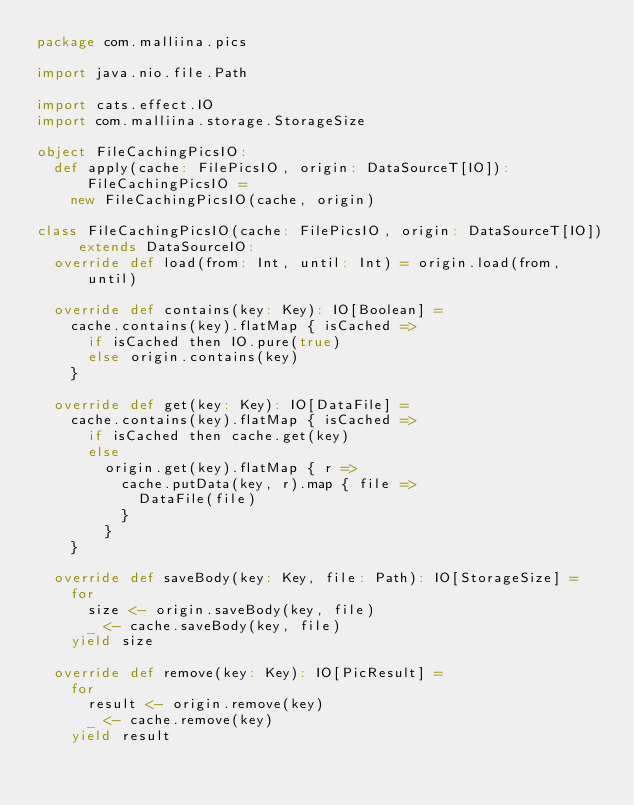Convert code to text. <code><loc_0><loc_0><loc_500><loc_500><_Scala_>package com.malliina.pics

import java.nio.file.Path

import cats.effect.IO
import com.malliina.storage.StorageSize

object FileCachingPicsIO:
  def apply(cache: FilePicsIO, origin: DataSourceT[IO]): FileCachingPicsIO =
    new FileCachingPicsIO(cache, origin)

class FileCachingPicsIO(cache: FilePicsIO, origin: DataSourceT[IO]) extends DataSourceIO:
  override def load(from: Int, until: Int) = origin.load(from, until)

  override def contains(key: Key): IO[Boolean] =
    cache.contains(key).flatMap { isCached =>
      if isCached then IO.pure(true)
      else origin.contains(key)
    }

  override def get(key: Key): IO[DataFile] =
    cache.contains(key).flatMap { isCached =>
      if isCached then cache.get(key)
      else
        origin.get(key).flatMap { r =>
          cache.putData(key, r).map { file =>
            DataFile(file)
          }
        }
    }

  override def saveBody(key: Key, file: Path): IO[StorageSize] =
    for
      size <- origin.saveBody(key, file)
      _ <- cache.saveBody(key, file)
    yield size

  override def remove(key: Key): IO[PicResult] =
    for
      result <- origin.remove(key)
      _ <- cache.remove(key)
    yield result
</code> 